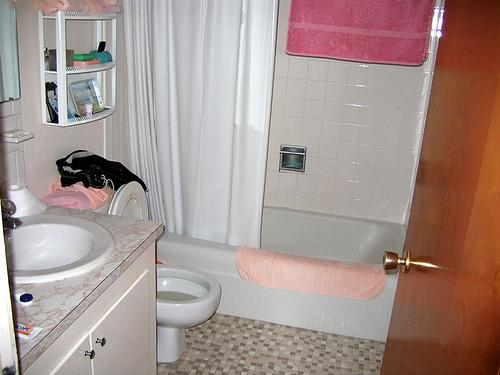Why is the shower curtain open?
Be succinct. To dry towel. Is this the bathroom?
Quick response, please. Yes. Does a man live in the home?
Answer briefly. Yes. Is there a shower curtain visible?
Answer briefly. Yes. 